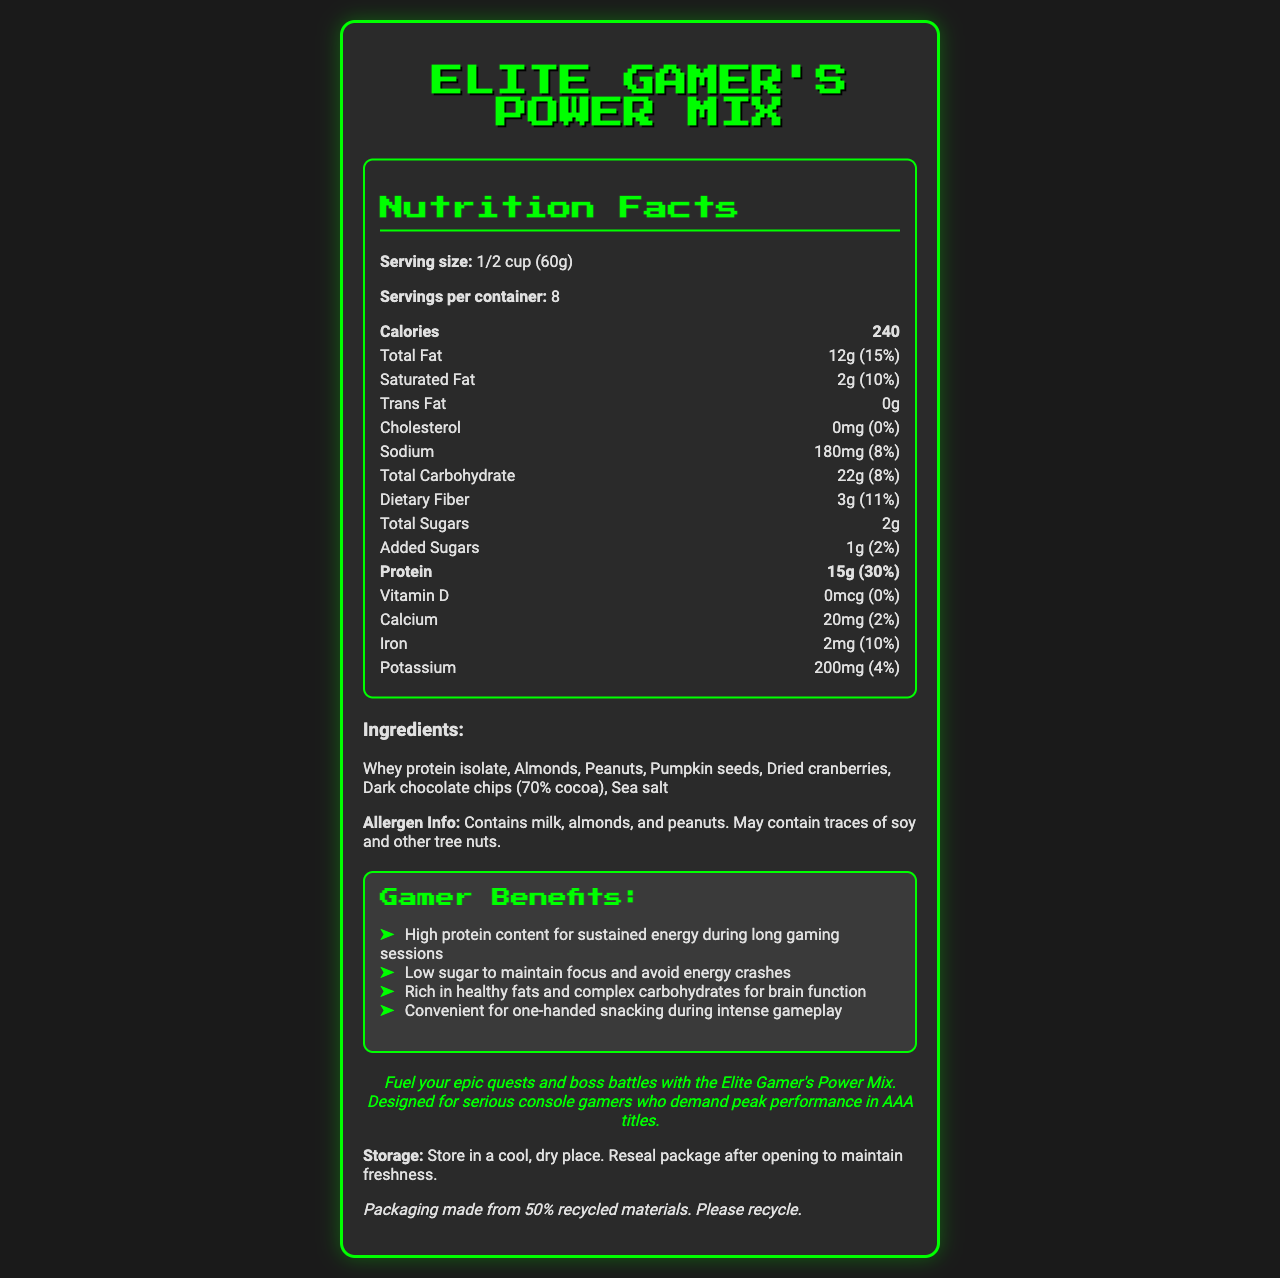what is the serving size of Elite Gamer's Power Mix? The serving size information is provided early in the nutrition facts section.
Answer: 1/2 cup (60g) how many servings are there per container? This information is located in the nutrition facts section under "Servings per container."
Answer: 8 how many calories are in one serving? The calorie content per serving is listed in the nutrition facts section.
Answer: 240 what is the amount of protein in one serving? The protein content is highlighted in the nutrition facts section.
Answer: 15g what are the total carbohydrates in one serving? The total carbohydrate content per serving is provided in the nutrition facts section.
Answer: 22g what ingredients are contained in Elite Gamer's Power Mix? The list of ingredients is shown under the ingredients section.
Answer: Whey protein isolate, Almonds, Peanuts, Pumpkin seeds, Dried cranberries, Dark chocolate chips (70% cocoa), Sea salt does this product contain any peanuts? The allergen information specifically mentions the presence of peanuts.
Answer: Yes what percentage of the daily value of iron is provided by one serving? The iron content and its daily value percentage are listed in the nutrition facts section.
Answer: 10% what is the amount of dietary fiber per serving? The dietary fiber amount is included in the total carbohydrate section.
Answer: 3g which vitamins or minerals are not present in this snack? A. Vitamin D B. Calcium C. Iron D. Potassium The nutrition facts show that Vitamin D has a value of 0mcg (0%).
Answer: A what allergen information is provided? The allergen information is clearly stated at the bottom of the ingredients section.
Answer: Contains milk, almonds, and peanuts. May contain traces of soy and other tree nuts. how does this snack benefit gamers? A. High protein for energy B. Low sugar C. Healthy fats and carbs for brain function D. All of the above The gamer benefits section lists all the options as benefits.
Answer: D is this product suitable for people with lactose intolerance? The allergen info indicates it contains milk, which may be an issue for those with lactose intolerance.
Answer: No summarize the main idea of the document The document gives comprehensive information about the snack mix, emphasizing its nutritional benefits for gamers and its convenience.
Answer: The document provides a detailed description of "Elite Gamer's Power Mix," a high-protein, low-sugar snack designed for gamers. It includes nutrition facts, ingredient list, allergen information, gamer benefits, storage instructions, sustainability note, and a gaming tie-in message encouraging gamers to fuel their performance with this mix. what is the exact amount of dark chocolate chips (70% cocoa) in one serving? The document lists dark chocolate chips as an ingredient but does not specify the exact amount per serving.
Answer: Not enough information 